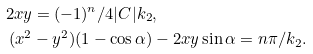Convert formula to latex. <formula><loc_0><loc_0><loc_500><loc_500>2 x y & = ( - 1 ) ^ { n } / 4 | C | k _ { 2 } , \\ ( x ^ { 2 } & - y ^ { 2 } ) ( 1 - \cos \alpha ) - 2 x y \sin \alpha = n \pi / k _ { 2 } .</formula> 